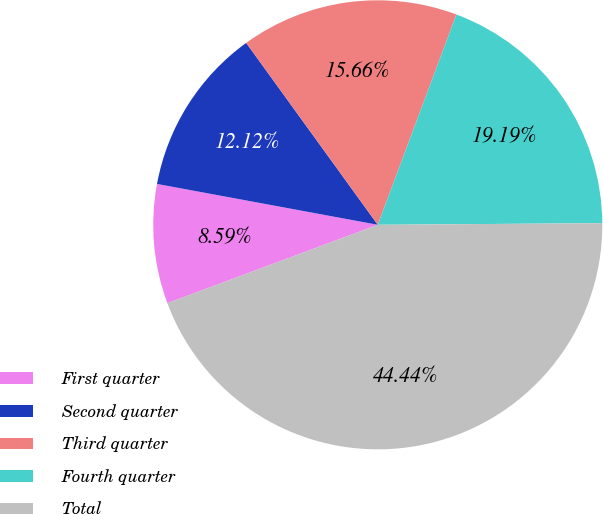Convert chart to OTSL. <chart><loc_0><loc_0><loc_500><loc_500><pie_chart><fcel>First quarter<fcel>Second quarter<fcel>Third quarter<fcel>Fourth quarter<fcel>Total<nl><fcel>8.59%<fcel>12.12%<fcel>15.66%<fcel>19.19%<fcel>44.44%<nl></chart> 